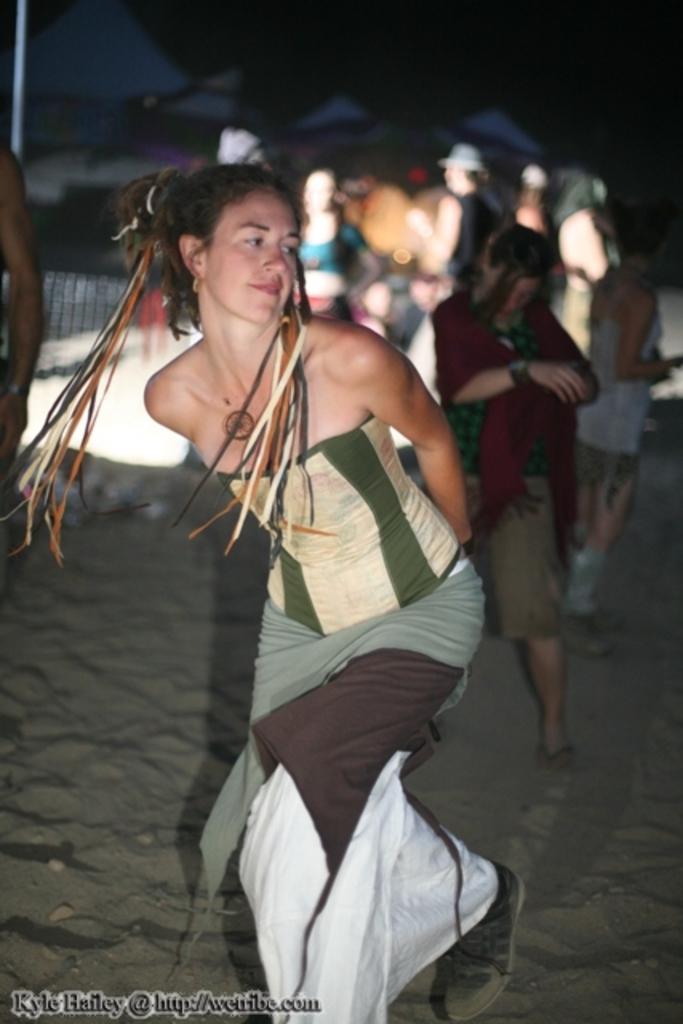Describe this image in one or two sentences. In this image there is a girl dancing in the sand. In the background there are few people standing on the ground. 